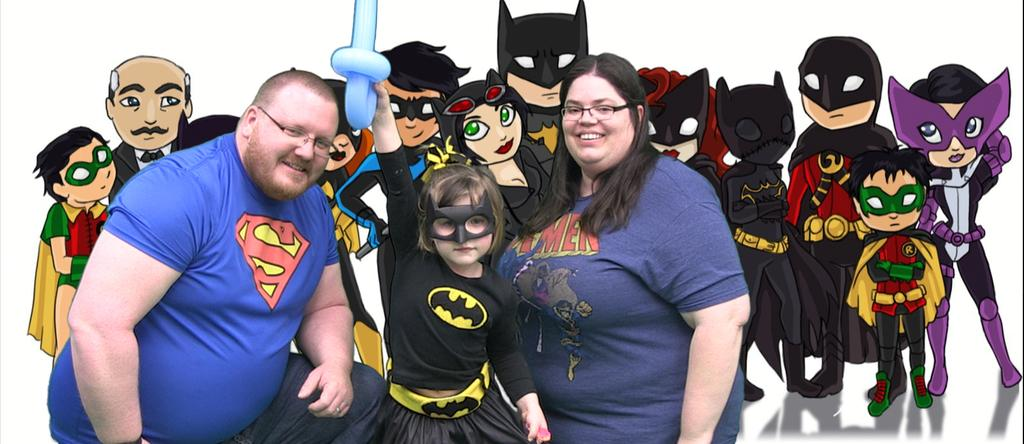What is happening in the center of the image? There are people in the center of the image. Can you describe the appearance of one of the people? One of the people is wearing a costume. What is the person in the costume holding? The person in the costume is holding an object. What can be seen in the background of the image? There are cartoon images in the background of the image. What type of voice does the boot have in the image? There is no boot present in the image, and therefore no voice can be attributed to it. 